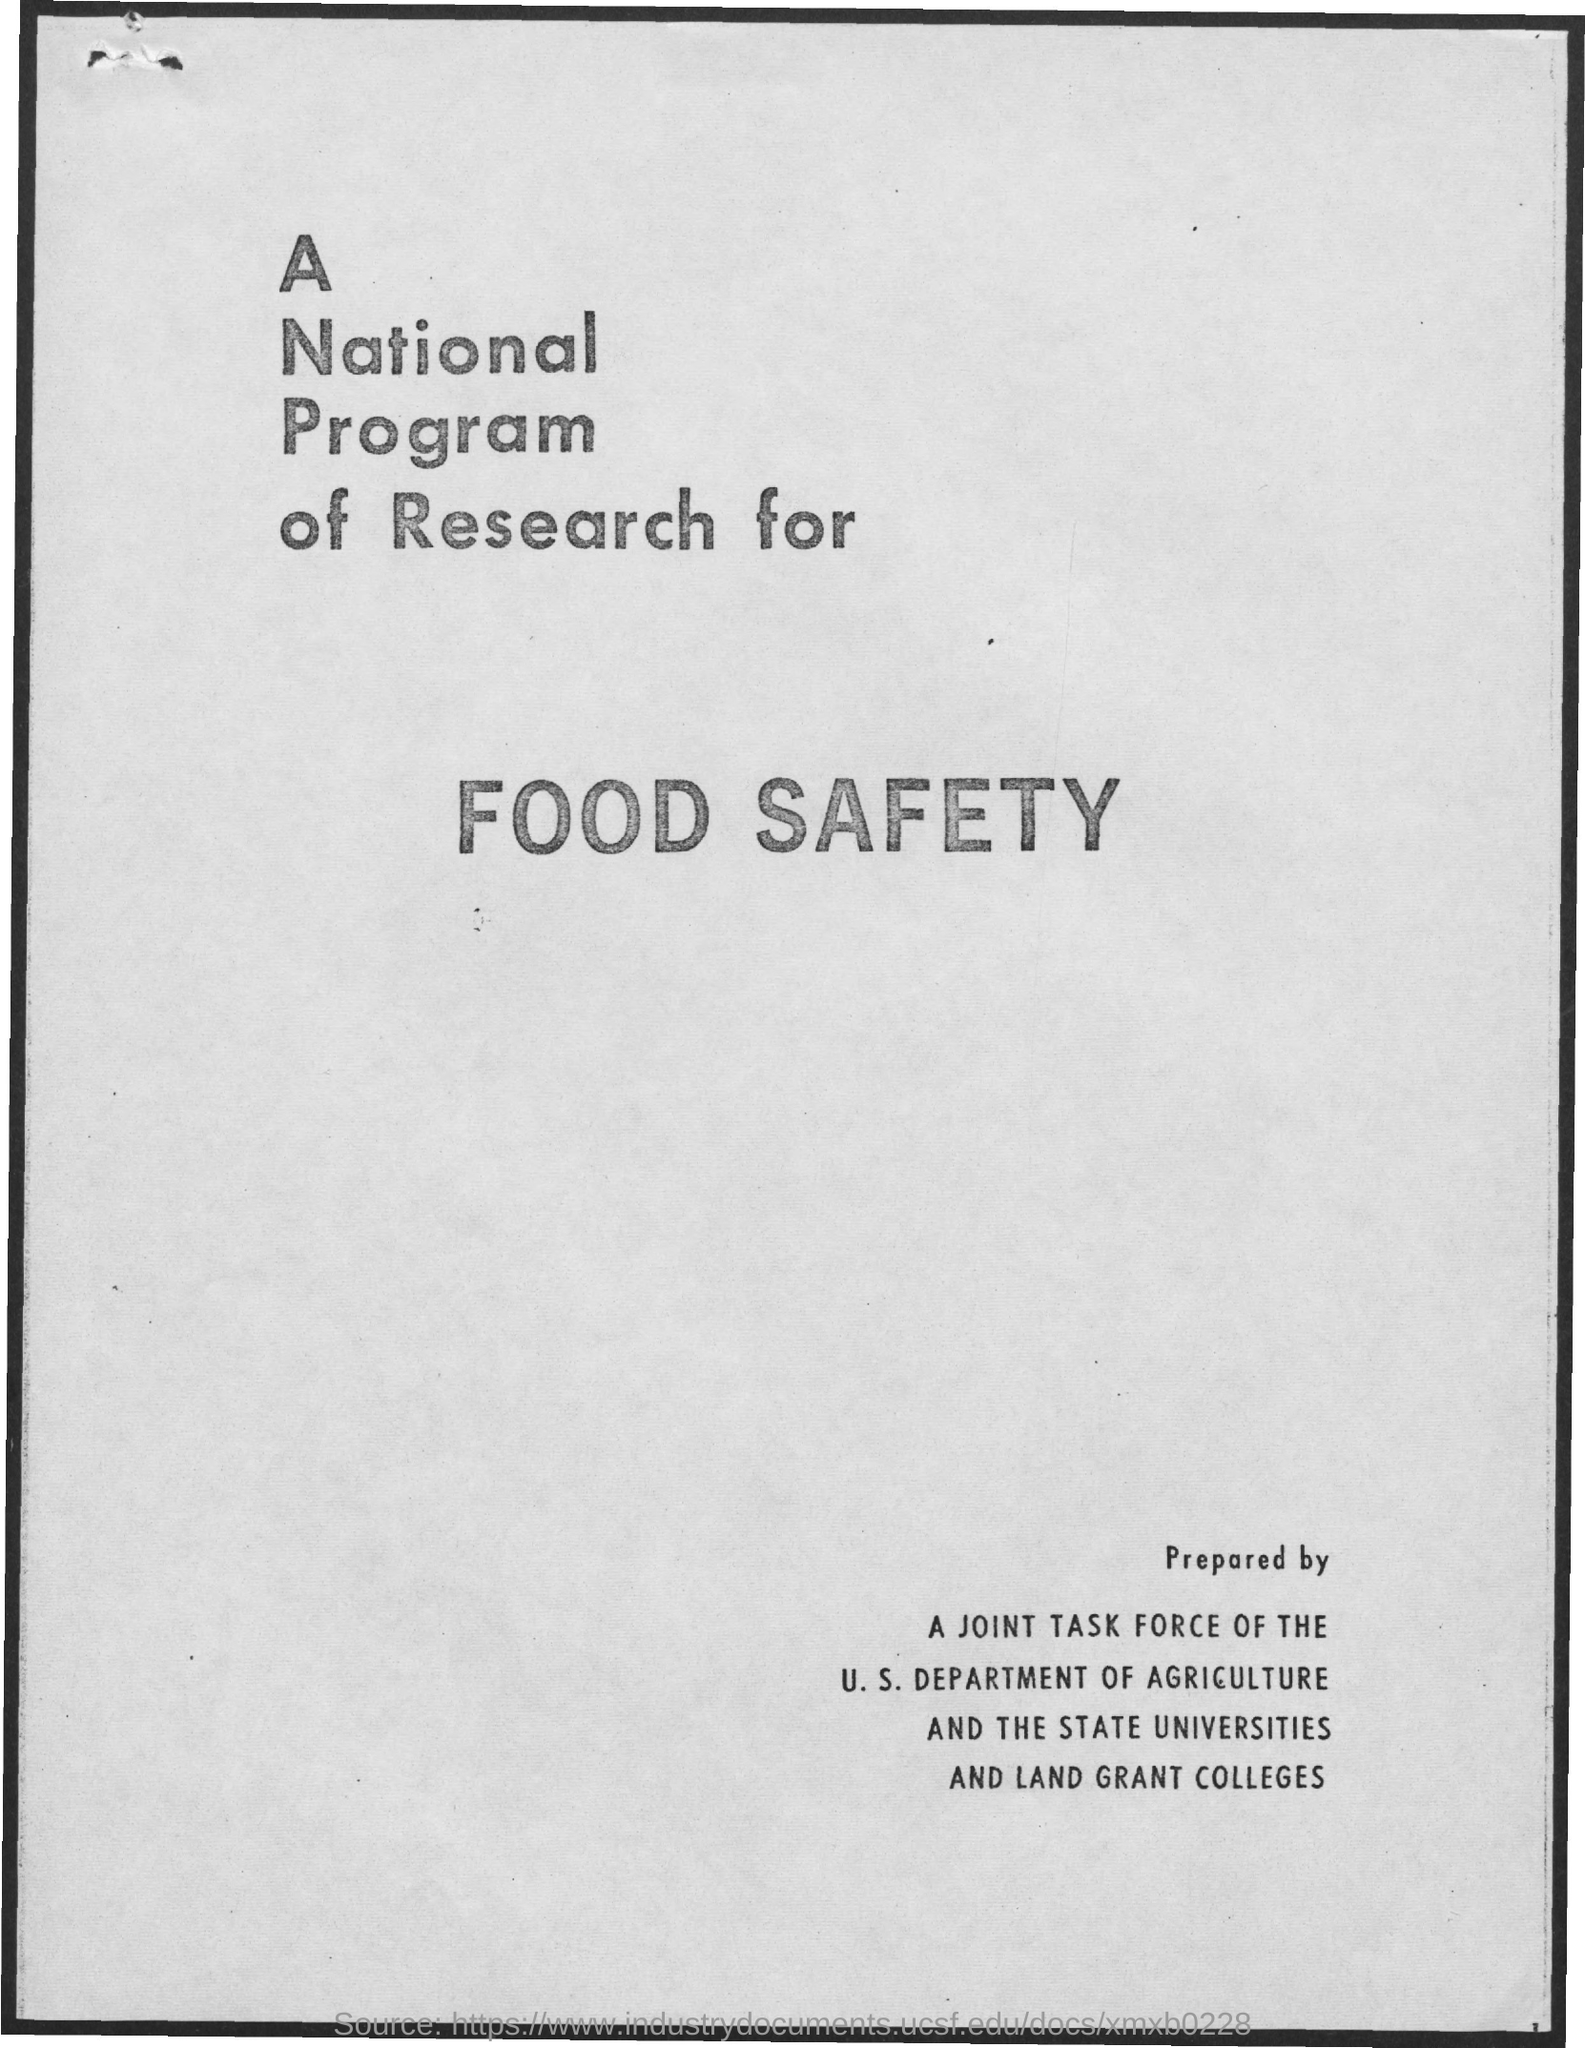What is the first title in the document?
Make the answer very short. A national program of research for. 